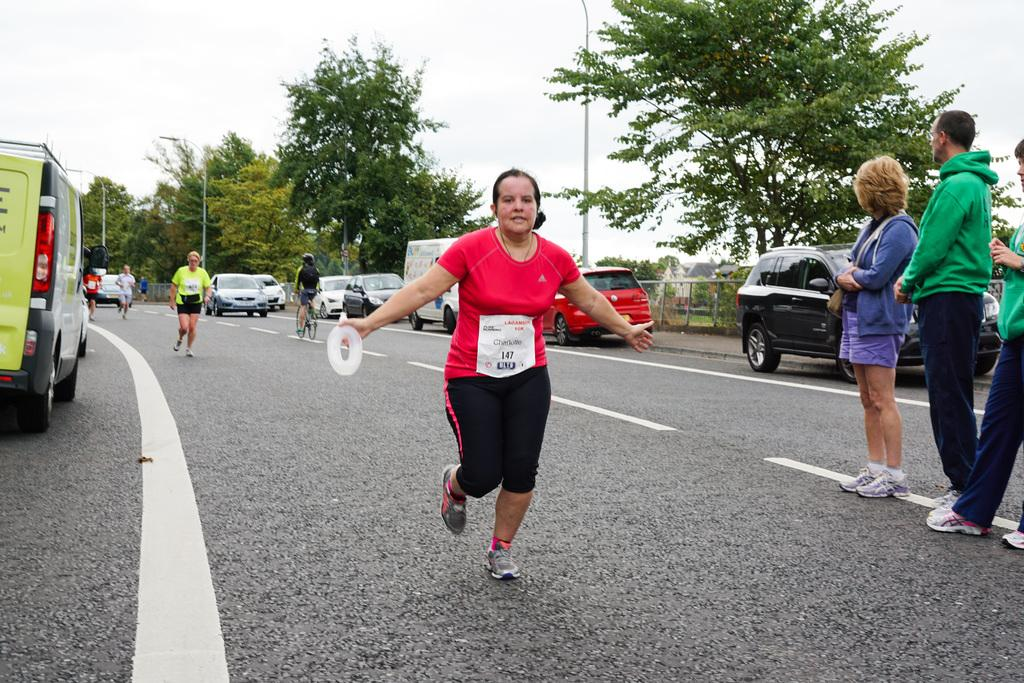What is the main feature of the image? There is a road in the image. What are the people on the road doing? Some people are running, and others are standing on the road. What can be seen on either side of the road? There are cars on either side of the road. What is visible in the background of the image? There are trees and poles in the background of the image. Where is the rose located in the image? There is no rose present in the image. What type of emotion is being expressed by the people in the image? The image does not show any specific emotions being expressed by the people; they are simply running or standing. 